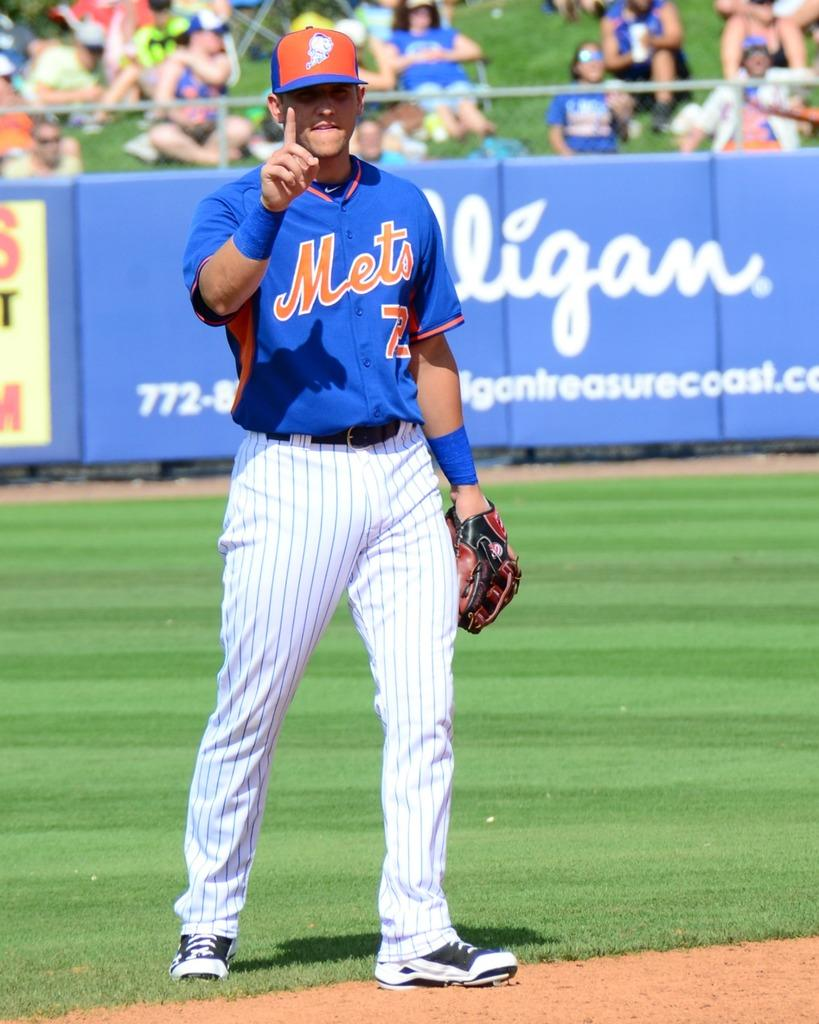<image>
Provide a brief description of the given image. A Mets baseball player wearing blue jersey is holding up his no 1 finger with a smile. 